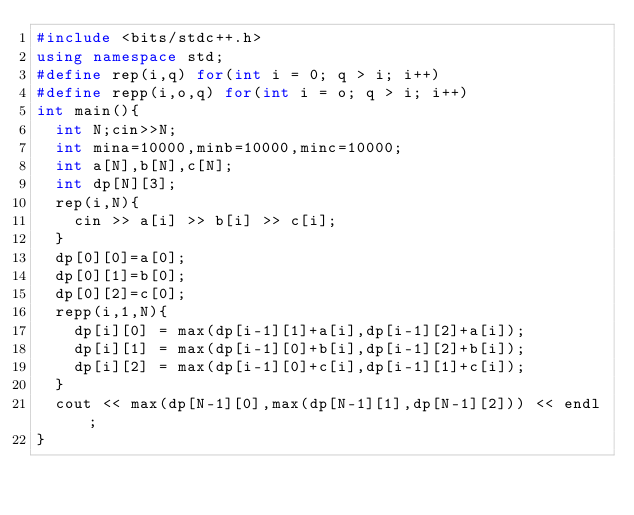Convert code to text. <code><loc_0><loc_0><loc_500><loc_500><_C++_>#include <bits/stdc++.h>
using namespace std;
#define rep(i,q) for(int i = 0; q > i; i++)
#define repp(i,o,q) for(int i = o; q > i; i++)
int main(){
  int N;cin>>N;
  int mina=10000,minb=10000,minc=10000;
  int a[N],b[N],c[N];
  int dp[N][3];
  rep(i,N){
    cin >> a[i] >> b[i] >> c[i];
  }
  dp[0][0]=a[0];
  dp[0][1]=b[0];
  dp[0][2]=c[0];
  repp(i,1,N){
    dp[i][0] = max(dp[i-1][1]+a[i],dp[i-1][2]+a[i]);
    dp[i][1] = max(dp[i-1][0]+b[i],dp[i-1][2]+b[i]);
    dp[i][2] = max(dp[i-1][0]+c[i],dp[i-1][1]+c[i]);
  }
  cout << max(dp[N-1][0],max(dp[N-1][1],dp[N-1][2])) << endl;
}</code> 